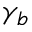<formula> <loc_0><loc_0><loc_500><loc_500>\gamma _ { b }</formula> 